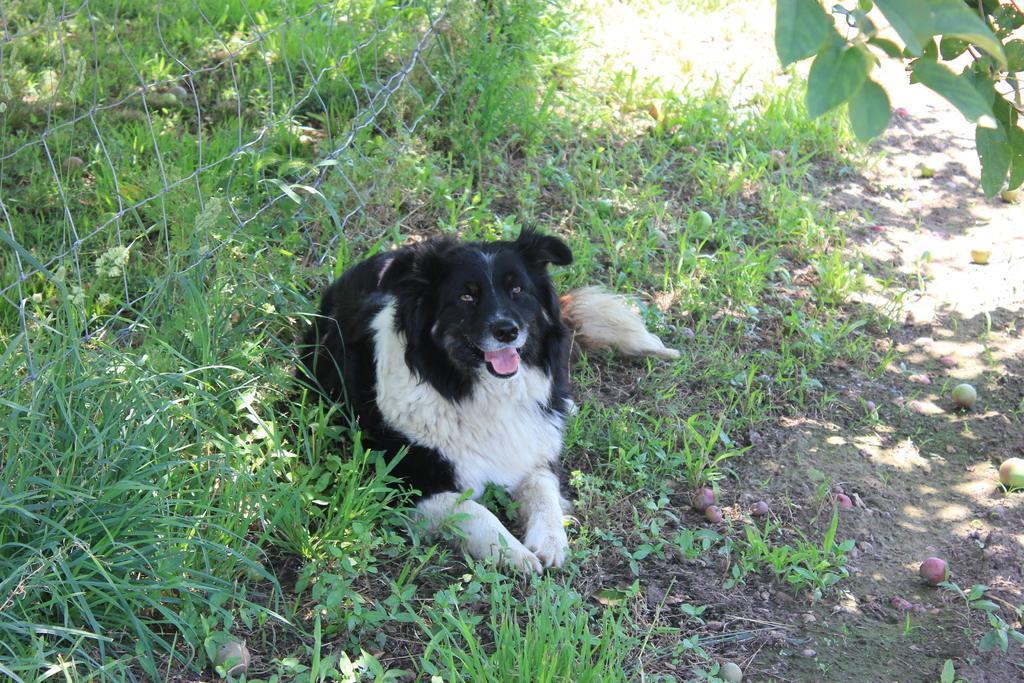Please provide a concise description of this image. In this image there is a dog on the land having grass and plants. Left side there is a fence. There are fruits on the land. Right top there are stems having leaves. 